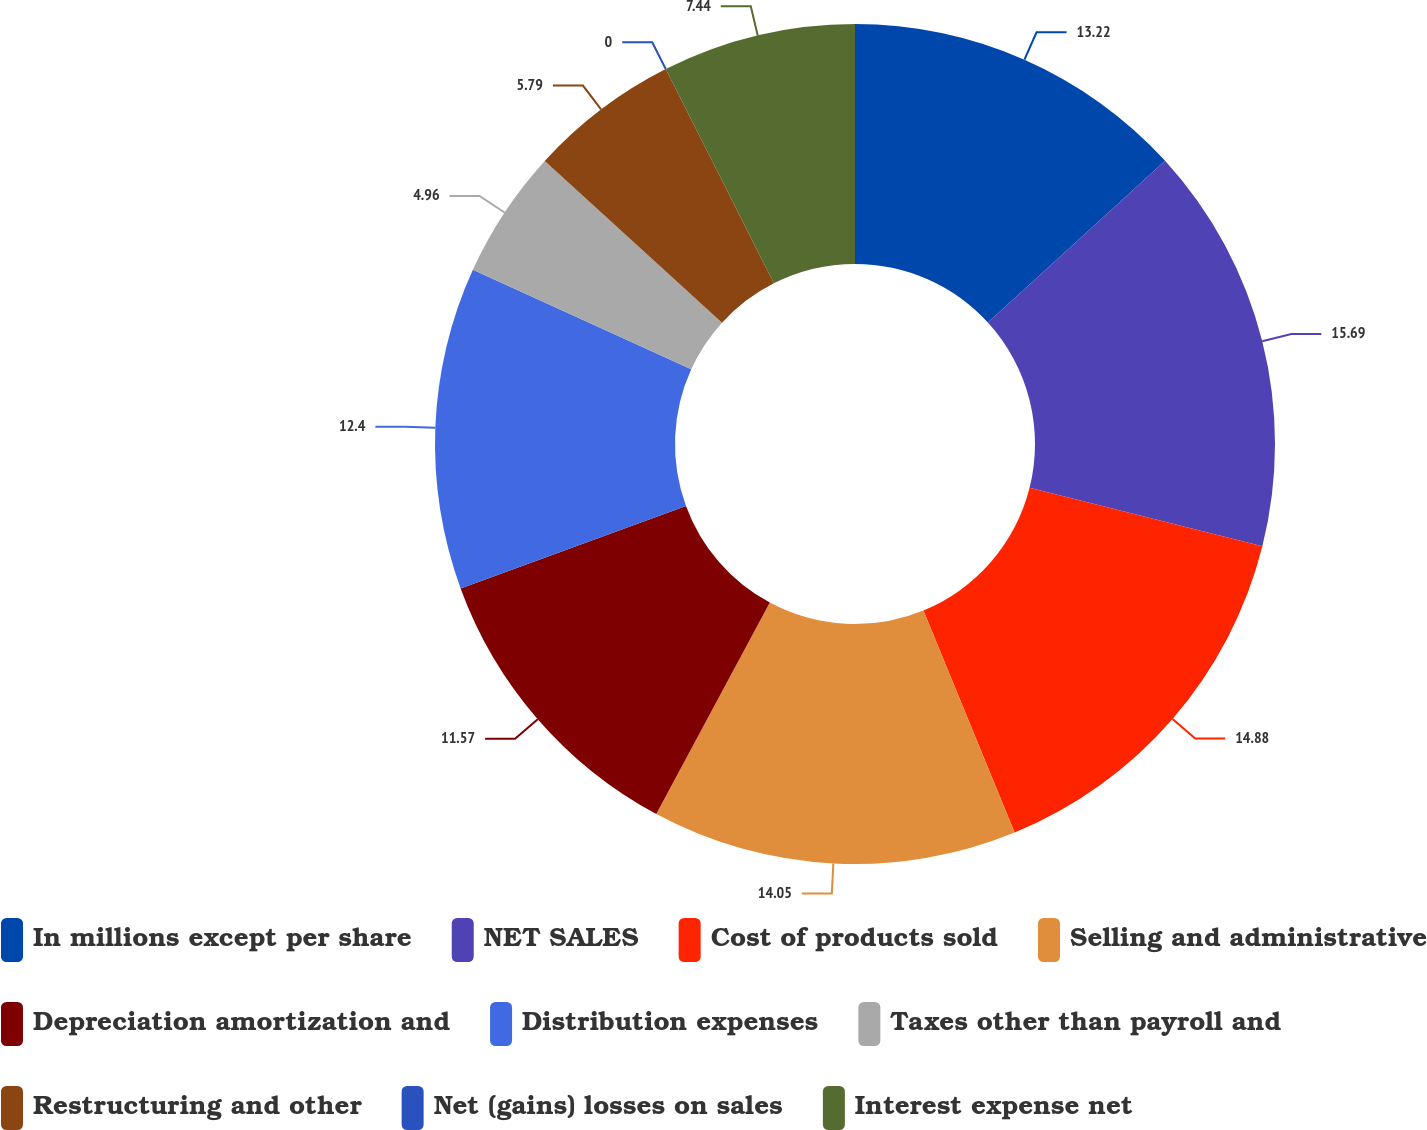Convert chart to OTSL. <chart><loc_0><loc_0><loc_500><loc_500><pie_chart><fcel>In millions except per share<fcel>NET SALES<fcel>Cost of products sold<fcel>Selling and administrative<fcel>Depreciation amortization and<fcel>Distribution expenses<fcel>Taxes other than payroll and<fcel>Restructuring and other<fcel>Net (gains) losses on sales<fcel>Interest expense net<nl><fcel>13.22%<fcel>15.7%<fcel>14.88%<fcel>14.05%<fcel>11.57%<fcel>12.4%<fcel>4.96%<fcel>5.79%<fcel>0.0%<fcel>7.44%<nl></chart> 